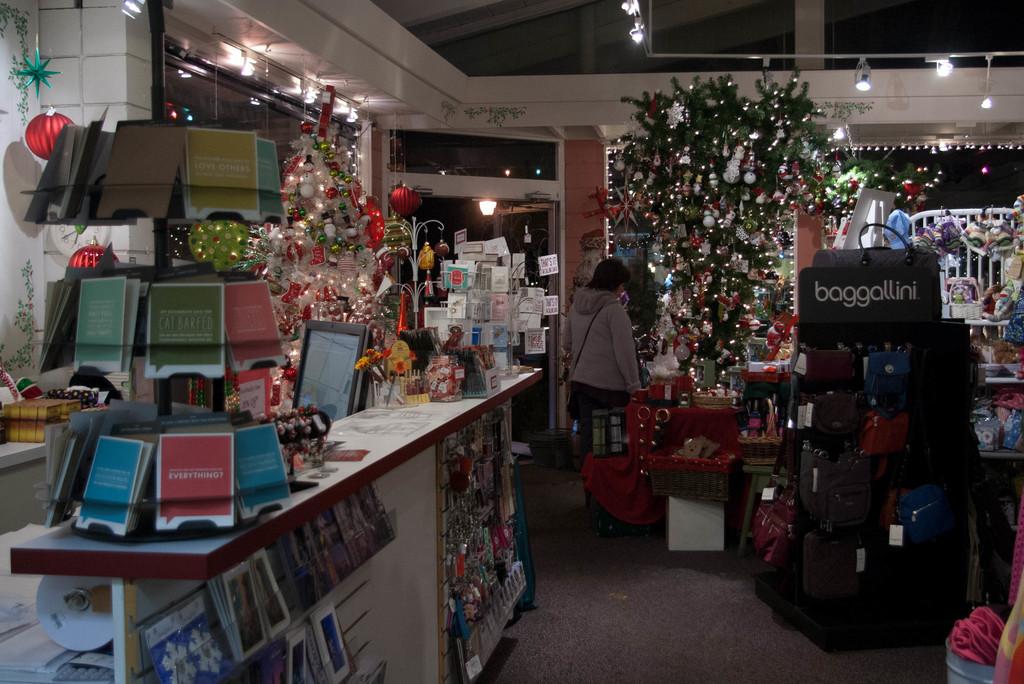What brand is featured on the black display?
Your response must be concise. Baggallini. According to the green card, what did the cat do?
Provide a short and direct response. Barfed. 